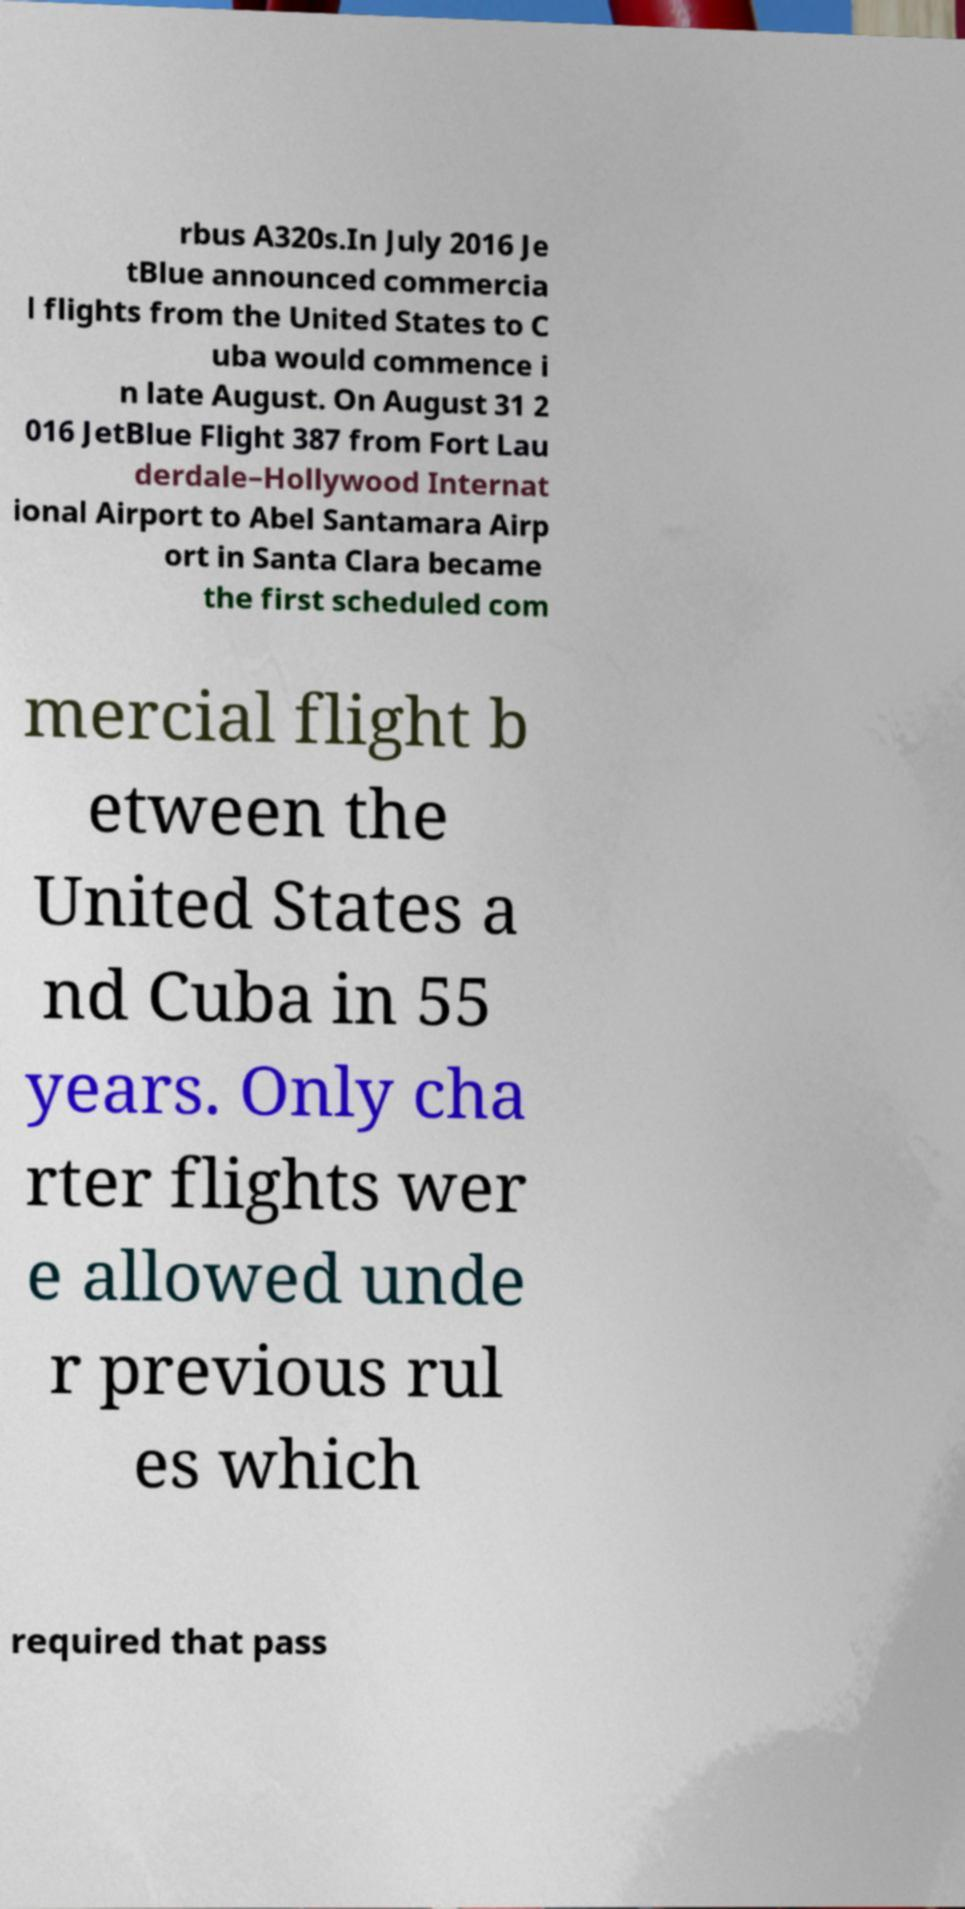There's text embedded in this image that I need extracted. Can you transcribe it verbatim? rbus A320s.In July 2016 Je tBlue announced commercia l flights from the United States to C uba would commence i n late August. On August 31 2 016 JetBlue Flight 387 from Fort Lau derdale–Hollywood Internat ional Airport to Abel Santamara Airp ort in Santa Clara became the first scheduled com mercial flight b etween the United States a nd Cuba in 55 years. Only cha rter flights wer e allowed unde r previous rul es which required that pass 